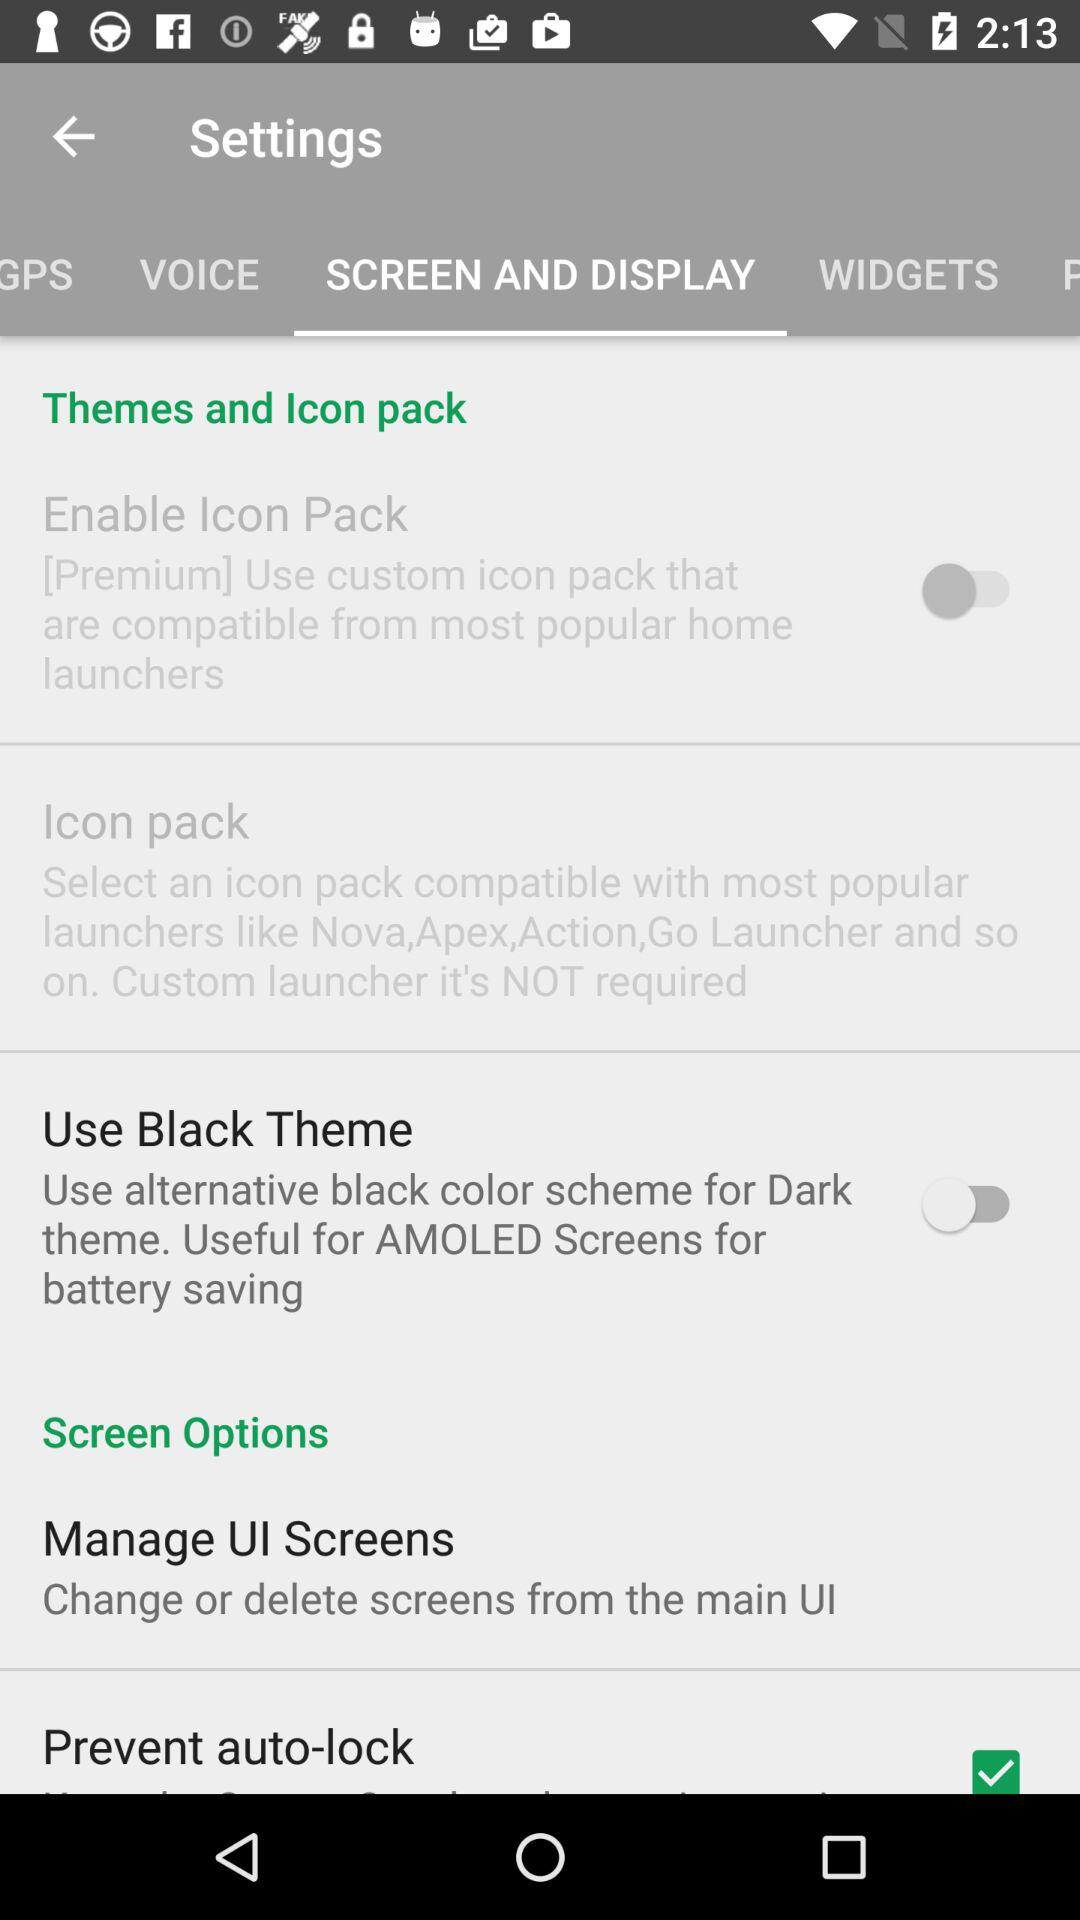What is the status of the "Enable Icon Pack"? The status is "off". 